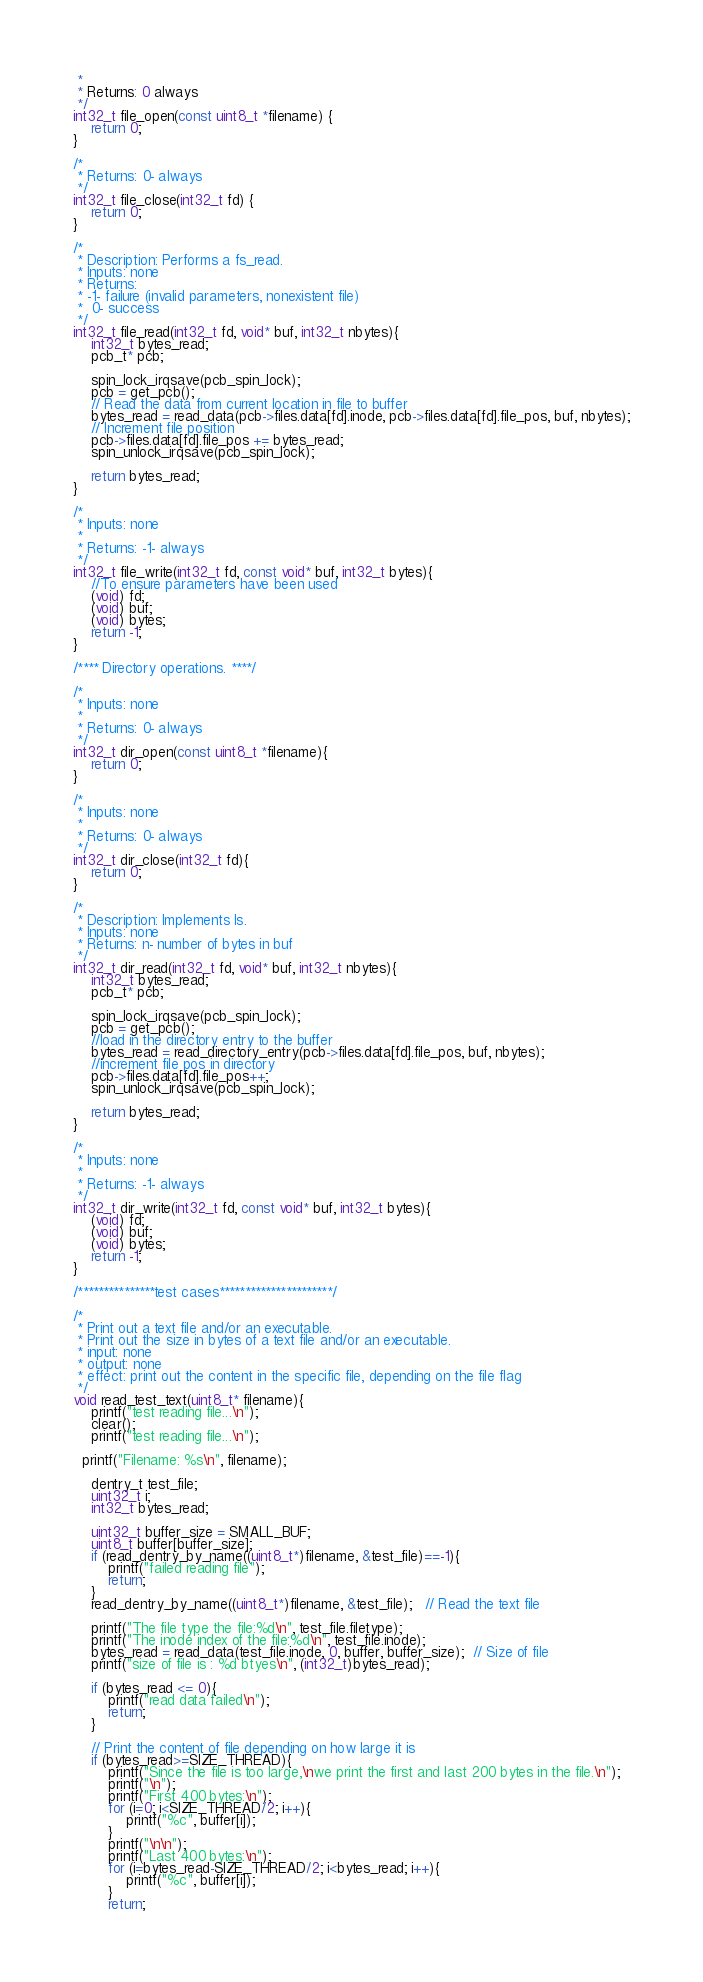<code> <loc_0><loc_0><loc_500><loc_500><_C_> *
 * Returns: 0 always
 */
int32_t file_open(const uint8_t *filename) {
	return 0;
}

/*
 * Returns: 0- always
 */
int32_t file_close(int32_t fd) {
	return 0;
}

/*
 * Description: Performs a fs_read.
 * Inputs: none
 * Returns:
 * -1- failure (invalid parameters, nonexistent file)
 *  0- success
 */
int32_t file_read(int32_t fd, void* buf, int32_t nbytes){
	int32_t bytes_read;
 	pcb_t* pcb;

 	spin_lock_irqsave(pcb_spin_lock);
 	pcb = get_pcb();
	// Read the data from current location in file to buffer
 	bytes_read = read_data(pcb->files.data[fd].inode, pcb->files.data[fd].file_pos, buf, nbytes);
	// Increment file position
 	pcb->files.data[fd].file_pos += bytes_read;
 	spin_unlock_irqsave(pcb_spin_lock);

 	return bytes_read;
}

/*
 * Inputs: none
 *
 * Returns: -1- always
 */
int32_t file_write(int32_t fd, const void* buf, int32_t bytes){
	//To ensure parameters have been used
	(void) fd;
	(void) buf;
	(void) bytes;
	return -1;
}

/**** Directory operations. ****/

/*
 * Inputs: none
 *
 * Returns: 0- always
 */
int32_t dir_open(const uint8_t *filename){
	return 0;
}

/*
 * Inputs: none
 *
 * Returns: 0- always
 */
int32_t dir_close(int32_t fd){
	return 0;
}

/*
 * Description: Implements ls.
 * Inputs: none
 * Returns: n- number of bytes in buf
 */
int32_t dir_read(int32_t fd, void* buf, int32_t nbytes){
	int32_t bytes_read;
 	pcb_t* pcb;

 	spin_lock_irqsave(pcb_spin_lock);
 	pcb = get_pcb();
	//load in the directory entry to the buffer
 	bytes_read = read_directory_entry(pcb->files.data[fd].file_pos, buf, nbytes);
	//increment file pos in directory
 	pcb->files.data[fd].file_pos++;
 	spin_unlock_irqsave(pcb_spin_lock);

 	return bytes_read;
}

/*
 * Inputs: none
 *
 * Returns: -1- always
 */
int32_t dir_write(int32_t fd, const void* buf, int32_t bytes){
	(void) fd;
	(void) buf;
	(void) bytes;
	return -1;
}

/***************test cases**********************/

/*
 * Print out a text file and/or an executable.
 * Print out the size in bytes of a text file and/or an executable.
 * input: none
 * output: none
 * effect: print out the content in the specific file, depending on the file flag
 */
void read_test_text(uint8_t* filename){
	printf("test reading file...\n");
	clear();
	printf("test reading file...\n");

  printf("Filename: %s\n", filename);

	dentry_t test_file;
	uint32_t i;
	int32_t bytes_read;

	uint32_t buffer_size = SMALL_BUF;
	uint8_t buffer[buffer_size];
	if (read_dentry_by_name((uint8_t*)filename, &test_file)==-1){
		printf("failed reading file");
		return;
	}
	read_dentry_by_name((uint8_t*)filename, &test_file);   // Read the text file

	printf("The file type the file:%d\n", test_file.filetype);
	printf("The inode index of the file:%d\n", test_file.inode);
	bytes_read = read_data(test_file.inode, 0, buffer, buffer_size);  // Size of file
	printf("size of file is : %d btyes\n", (int32_t)bytes_read);

	if (bytes_read <= 0){
		printf("read data failed\n");
		return;
	}

	// Print the content of file depending on how large it is
	if (bytes_read>=SIZE_THREAD){
		printf("Since the file is too large,\nwe print the first and last 200 bytes in the file.\n");
		printf("\n");
		printf("First 400 bytes:\n");
		for (i=0; i<SIZE_THREAD/2; i++){
			printf("%c", buffer[i]);
		}
		printf("\n\n");
		printf("Last 400 bytes:\n");
		for (i=bytes_read-SIZE_THREAD/2; i<bytes_read; i++){
			printf("%c", buffer[i]);
		}
		return;</code> 